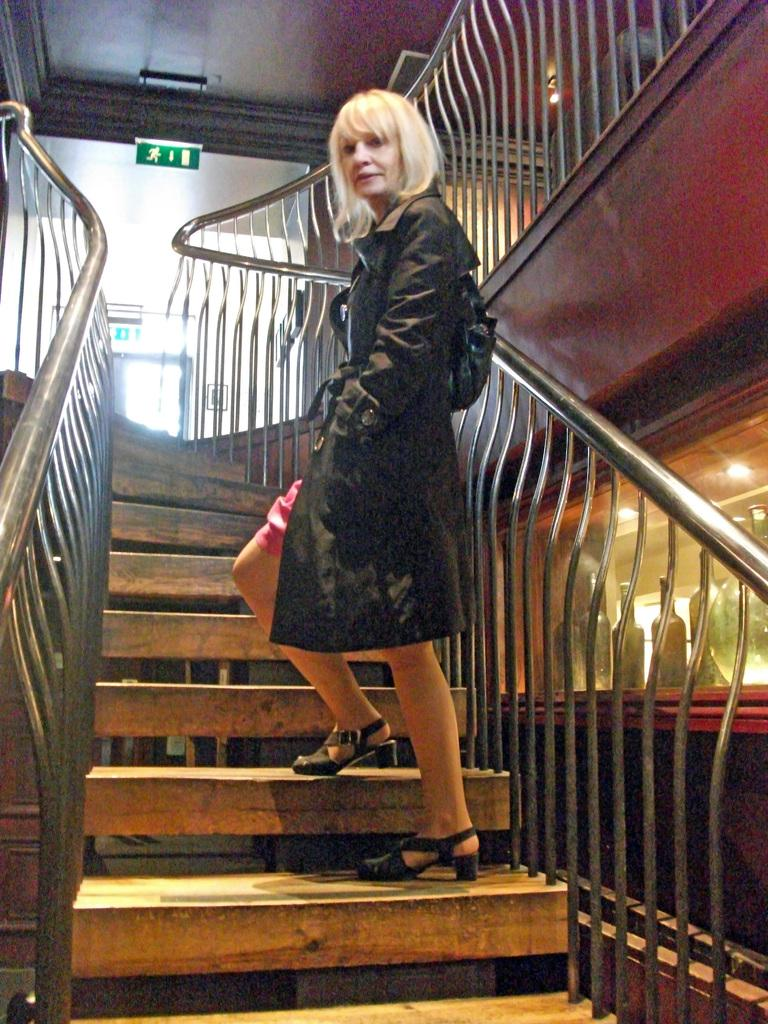What type of structure is present in the image? There are stairs in the image. Can you describe the person in the image? There is a woman in the image, and she is wearing a black dress. What objects can be seen on the right side of the image? There are bottles on the right side of the image. What is the maid doing with the queen in the image? There is no maid or queen present in the image. 